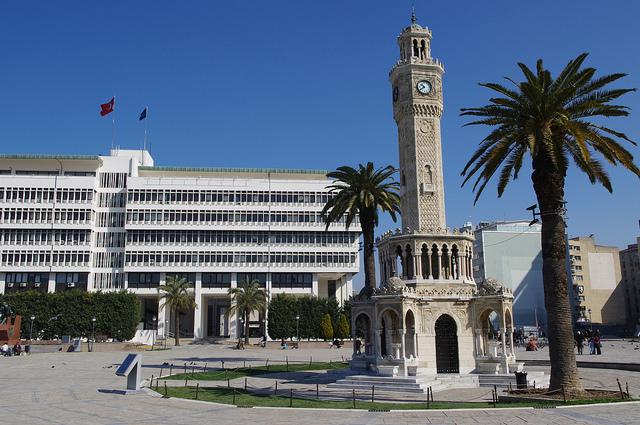What type of building is the one furthest away from the viewer?
Answer briefly. Office. Is this an old building?
Give a very brief answer. Yes. What color is the photo?
Concise answer only. Multi. Is this building still being used today?
Keep it brief. Yes. How many windows from the right is the flag flying on the yellow building?
Write a very short answer. 0. Is this a tourist friendly area?
Keep it brief. Yes. What year was the clock tower made?
Write a very short answer. 1500. How many people are in the building?
Quick response, please. 100. 